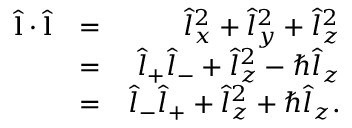Convert formula to latex. <formula><loc_0><loc_0><loc_500><loc_500>\begin{array} { r l r } { \hat { l } \cdot \hat { l } } & { = } & { \hat { l } _ { x } ^ { 2 } + \hat { l } _ { y } ^ { 2 } + \hat { l } _ { z } ^ { 2 } } \\ & { = } & { \hat { l } _ { + } \hat { l } _ { - } + \hat { l } _ { z } ^ { 2 } - \hbar { \hat } { l } _ { z } } \\ & { = } & { \hat { l } _ { - } \hat { l } _ { + } + \hat { l } _ { z } ^ { 2 } + \hbar { \hat } { l } _ { z } . } \end{array}</formula> 